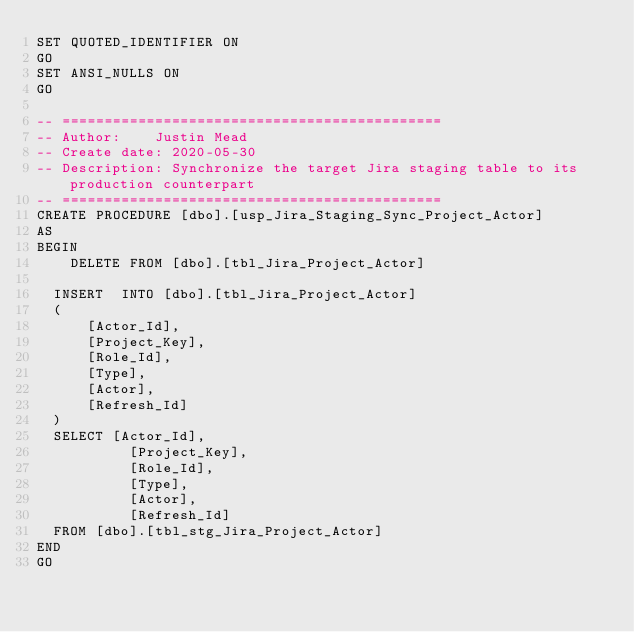Convert code to text. <code><loc_0><loc_0><loc_500><loc_500><_SQL_>SET QUOTED_IDENTIFIER ON
GO
SET ANSI_NULLS ON
GO

-- =============================================
-- Author:		Justin Mead
-- Create date: 2020-05-30
-- Description:	Synchronize the target Jira staging table to its production counterpart
-- =============================================
CREATE PROCEDURE [dbo].[usp_Jira_Staging_Sync_Project_Actor]
AS
BEGIN
    DELETE FROM	[dbo].[tbl_Jira_Project_Actor]

	INSERT	INTO [dbo].[tbl_Jira_Project_Actor]
	(
	    [Actor_Id],
	    [Project_Key],
	    [Role_Id],
	    [Type],
	    [Actor],
	    [Refresh_Id]
	)
	SELECT [Actor_Id],
           [Project_Key],
           [Role_Id],
           [Type],
           [Actor],
           [Refresh_Id]
	FROM [dbo].[tbl_stg_Jira_Project_Actor]
END
GO
</code> 